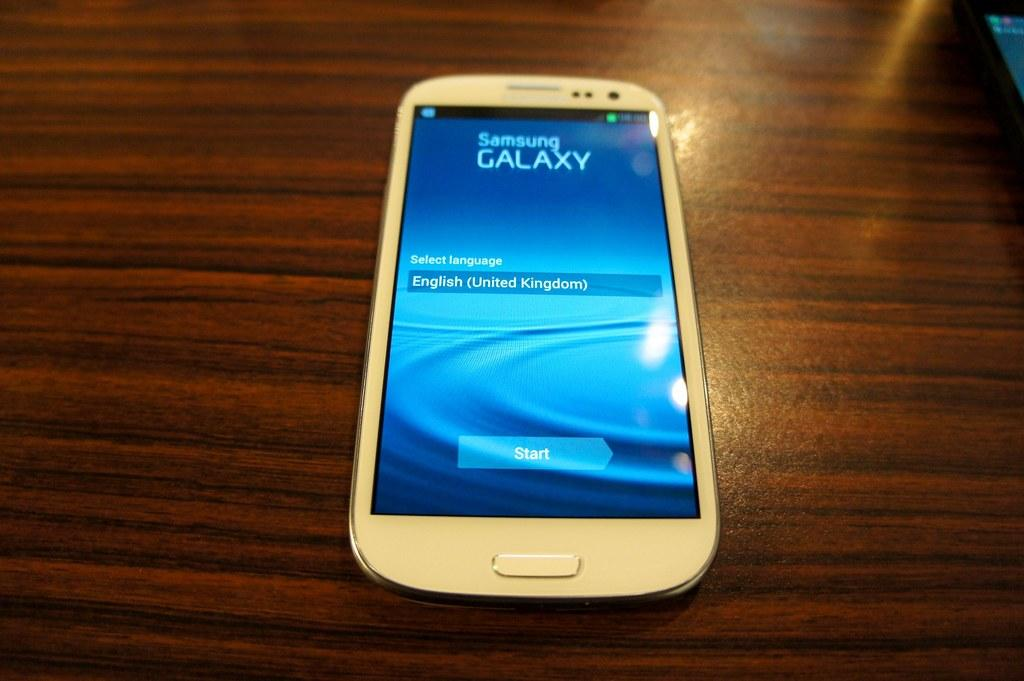What is the main object in the center of the image? There is a table in the center of the image. What is placed on the table? A mobile is present on the table. How many ducks are sitting on the sofa in the image? There are no ducks or sofa present in the image. What type of fruit is displayed on the table in the image? There is no fruit displayed on the table in the image; only a mobile is present. 